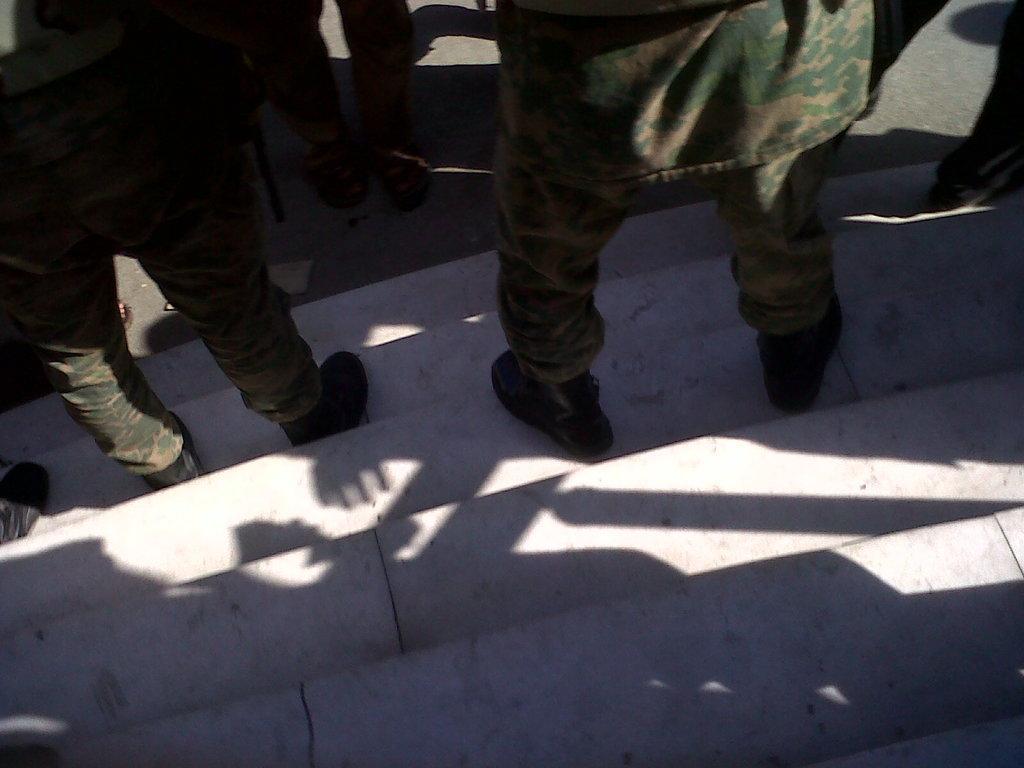In one or two sentences, can you explain what this image depicts? In this picture, we see the legs of men wearing uniforms and shoes are standing on the staircase. Beside the staircase, we see the road. 